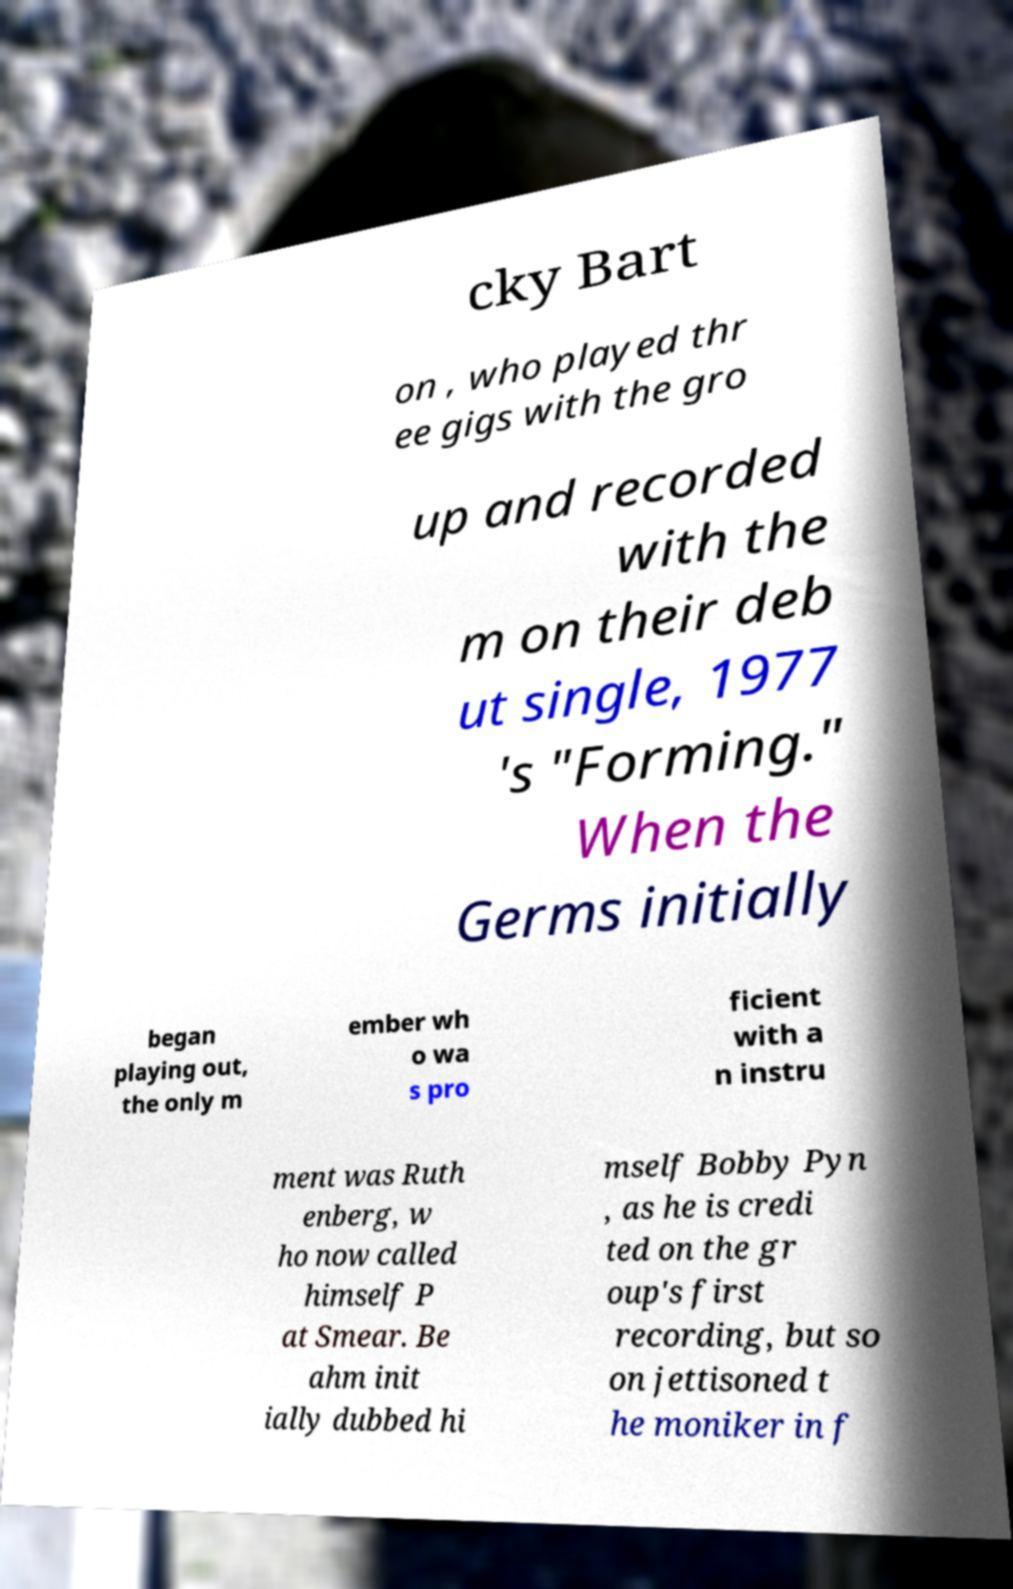I need the written content from this picture converted into text. Can you do that? cky Bart on , who played thr ee gigs with the gro up and recorded with the m on their deb ut single, 1977 's "Forming." When the Germs initially began playing out, the only m ember wh o wa s pro ficient with a n instru ment was Ruth enberg, w ho now called himself P at Smear. Be ahm init ially dubbed hi mself Bobby Pyn , as he is credi ted on the gr oup's first recording, but so on jettisoned t he moniker in f 